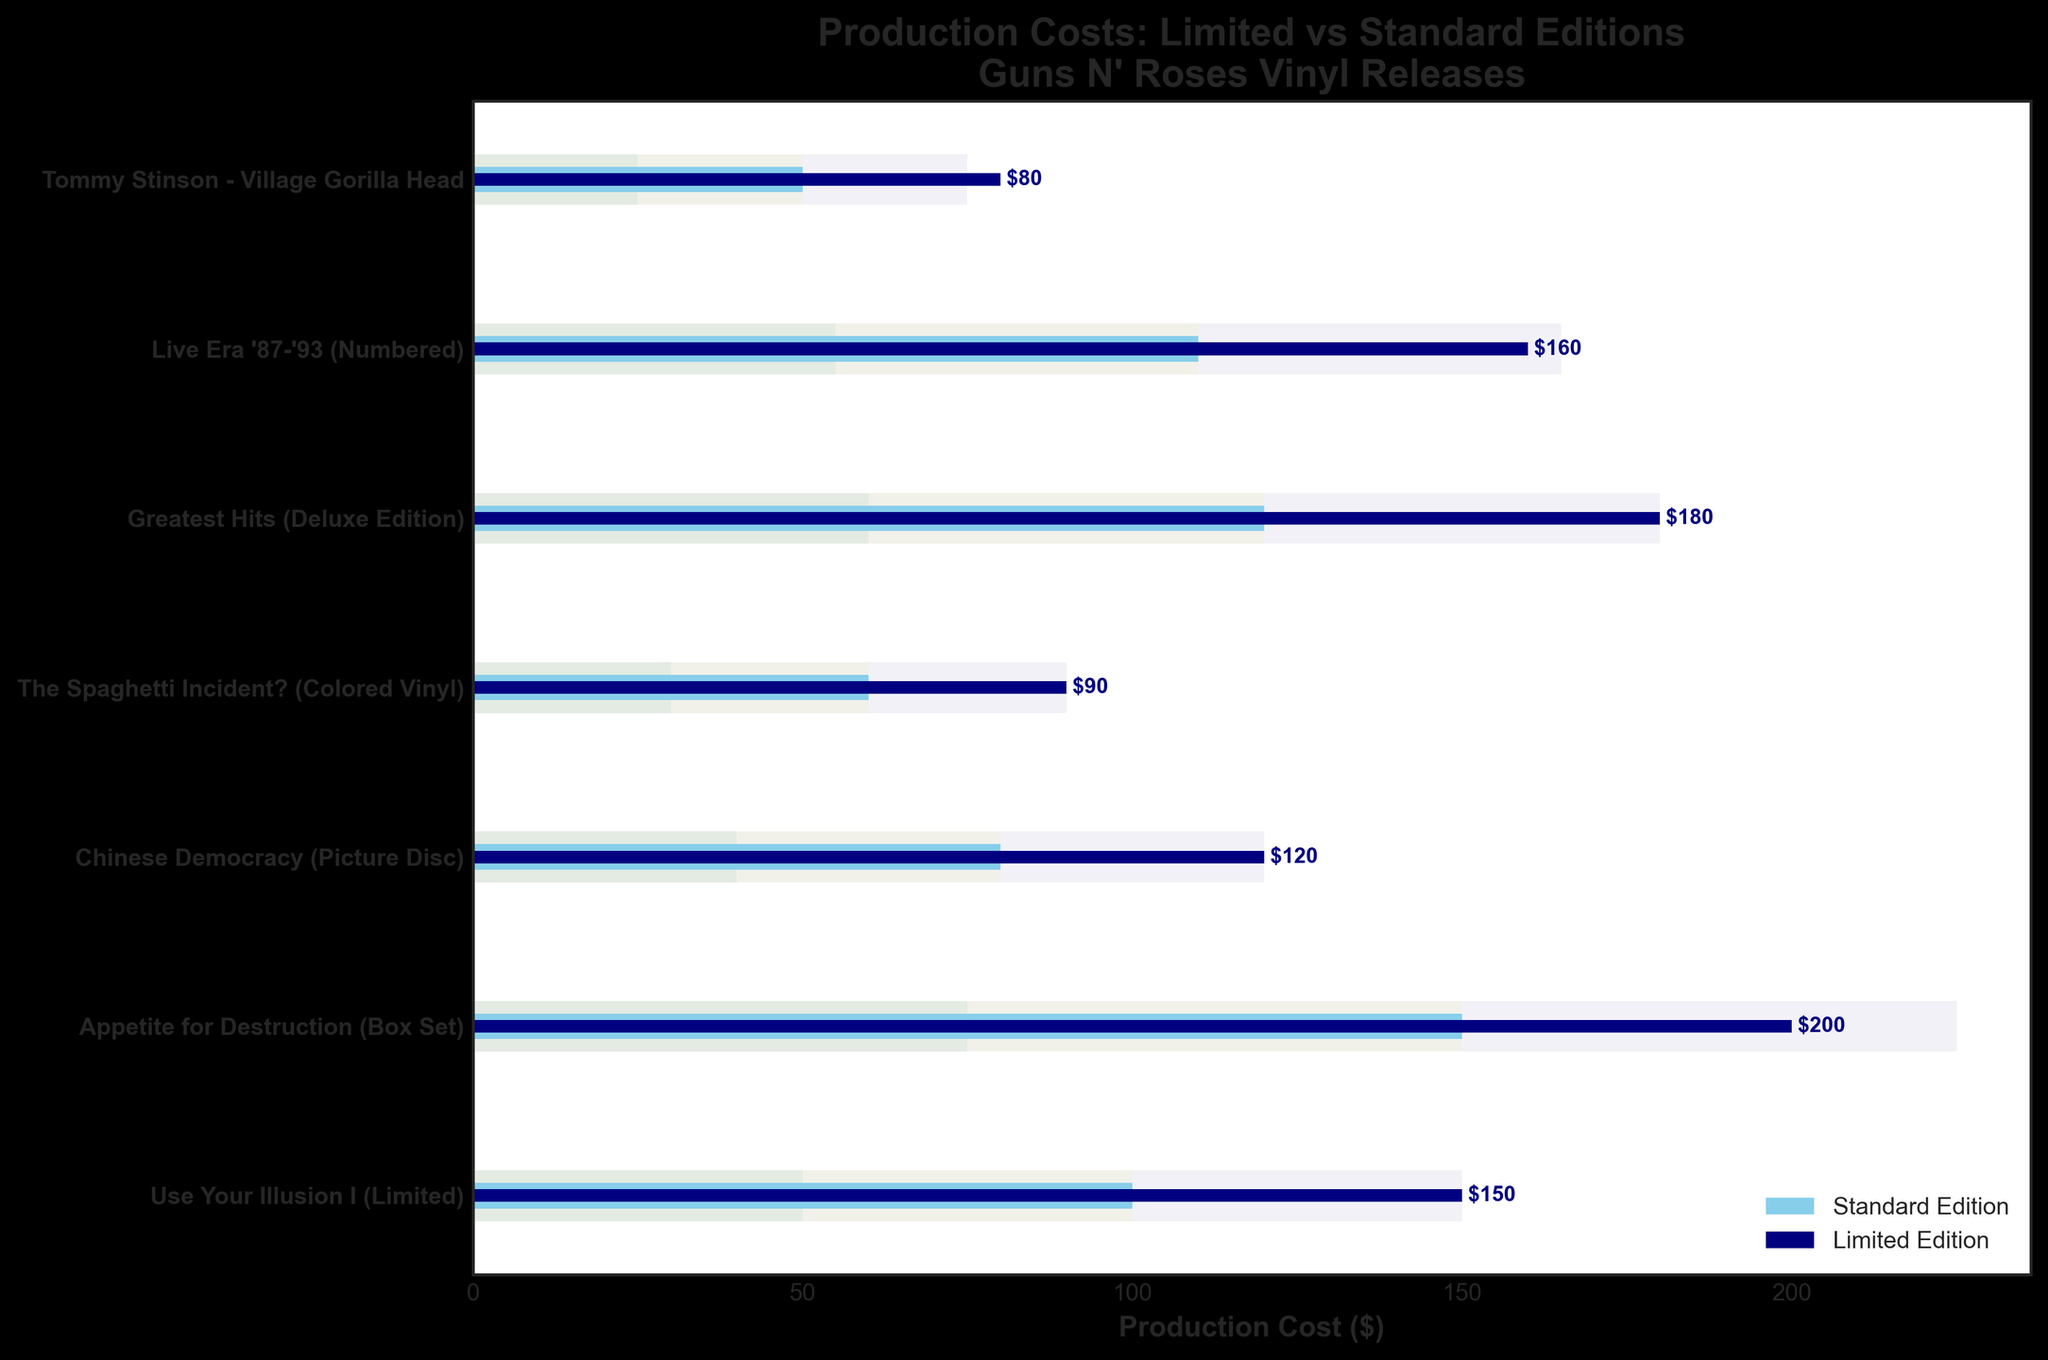what is the title of the chart? The title of the chart is written at the top, just above the main plotting area.
Answer: Production Costs: Limited vs Standard Editions Guns N' Roses Vinyl Releases How many vinyl releases are analyzed in this chart? Count the number of data points in the chart, which correspond to the y-axis labels.
Answer: 7 What is the production cost of the Limited Edition of "Appetite for Destruction (Box Set)"? Locate "Appetite for Destruction (Box Set)" on the y-axis and look for the corresponding bar color for Limited Edition production costs.
Answer: 200 Which vinyl release has the highest production cost for the Standard Edition? Compare the lengths of the lighter blue bars which represent Standard Edition costs and find the longest one.
Answer: Appetite for Destruction (Box Set) What is the range for the production cost of the Limited Edition of "Chinese Democracy (Picture Disc)"? Locate "Chinese Democracy (Picture Disc)" and look at the shaded areas for the range values. The ranges are represented in a gradient from left to right.
Answer: 0-120 What is the difference in production cost between the Limited Edition and the Standard Edition of "Live Era '87-'93 (Numbered)"? Find the values of both editions for this release and subtract the Standard Edition cost from the Limited Edition cost (160 - 110).
Answer: 50 What is the average production cost of all the Limited Edition releases? Add up the production costs of all the Limited Editions (150 + 200 + 120 + 90 + 180 + 160 + 80) and divide by the number of releases (7).
Answer: 140 Which vinyl release has the smallest difference in production cost between the Limited Edition and Standard Edition? Calculate the differences for each vinyl release and identify the smallest. For instance, Chinese Democracy: (120 - 80) = 40, may need to do for all releases.
Answer: Chinese Democracy (Picture Disc) How does the production cost of the Limited Edition of "Greatest Hits (Deluxe Edition)" compare to its upper value range? Find the Limited Edition bar for "Greatest Hits (Deluxe Edition)" and compare it to the upper range value shaded area.
Answer: Equal What is the median production cost of all Standard Editions? List the production costs of the Standard Editions (100, 150, 80, 60, 120, 110, 50) in order and find the middle value.
Answer: 100 